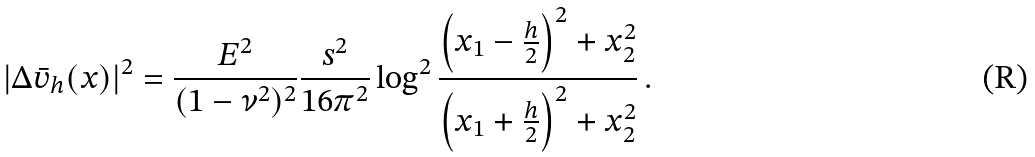<formula> <loc_0><loc_0><loc_500><loc_500>| \Delta \bar { v } _ { h } ( x ) | ^ { 2 } = \frac { E ^ { 2 } } { ( 1 - \nu ^ { 2 } ) ^ { 2 } } \frac { s ^ { 2 } } { 1 6 \pi ^ { 2 } } \log ^ { 2 } \frac { \left ( x _ { 1 } - \frac { h } { 2 } \right ) ^ { 2 } + x _ { 2 } ^ { 2 } } { \left ( x _ { 1 } + \frac { h } { 2 } \right ) ^ { 2 } + x _ { 2 } ^ { 2 } } \, .</formula> 